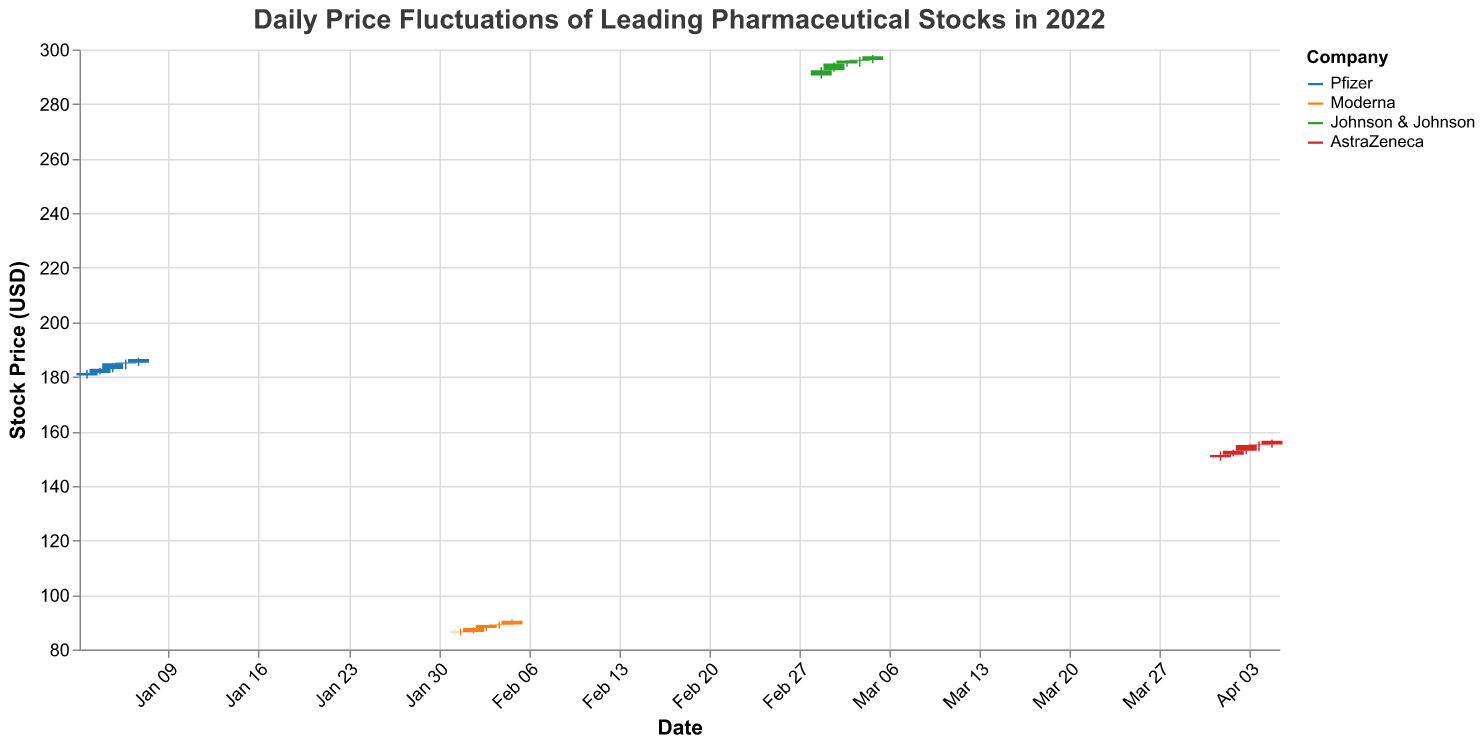What is the title of the chart? The title is located at the top center of the chart, indicating what the chart represents. It states "Daily Price Fluctuations of Leading Pharmaceutical Stocks in 2022".
Answer: Daily Price Fluctuations of Leading Pharmaceutical Stocks in 2022 Which company has the highest trading volume on a single day? Review the "Volume" field across all companies and identify the maximum value. The highest volume is 5,900,000 on April 5, 2022, for AstraZeneca.
Answer: AstraZeneca What is the closing price of Pfizer on January 5, 2022? Locate Pfizer's data for January 5, 2022, and check the "Close" value, which is part of the tooltip or the candlestick. The closing price is 184.95.
Answer: 184.95 Between Moderna and Johnson & Johnson, which company had a higher highest stock price on any given day? Compare the highest stock prices for both companies across the given dates. Johnson & Johnson's highest price on March 5, 2022, is 298.00, which is higher than Moderna's highest price of 91.00.
Answer: Johnson & Johnson How does the color represent different companies in the chart? The color legend shows different colors for each company: Pfizer (blue), Moderna (orange), Johnson & Johnson (green), and AstraZeneca (red).
Answer: Pfizer (blue), Moderna (orange), Johnson & Johnson (green), AstraZeneca (red) What was the opening price of AstraZeneca on April 1, 2022? Locate AstraZeneca's data for April 1, 2022, and look at the "Open" value. The opening price is 150.50.
Answer: 150.50 Which company showed the greatest increase in closing price between the first and the last day in the dataset? Calculate the difference between the first and last closing prices for each company. Pfizer increased from 181.35 to 186.50 (+5.15), Moderna from 86.35 to 90.50 (+4.15), Johnson & Johnson from 292.35 to 297.50 (+5.15), and AstraZeneca from 151.35 to 156.50 (+5.15). They all increased by 5.15.
Answer: Pfizer, Johnson & Johnson, AstraZeneca On which day did Johnson & Johnson have its highest closing price? Cross-reference the dates for Johnson & Johnson and find the day with the highest closing price. The highest closing price is 297.50 on March 5, 2022.
Answer: March 5, 2022 How many total days of data are provided for Moderna? Count the entries with "Moderna" as the company. There are five entries, one for each day from February 1 to February 5, 2022.
Answer: 5 Which company had the lowest low price in the dataset, and what was that price? Examine the "Low" prices across all companies and find the minimum value. Moderna on February 1, 2022, had the lowest low price at 85.25.
Answer: Moderna, 85.25 